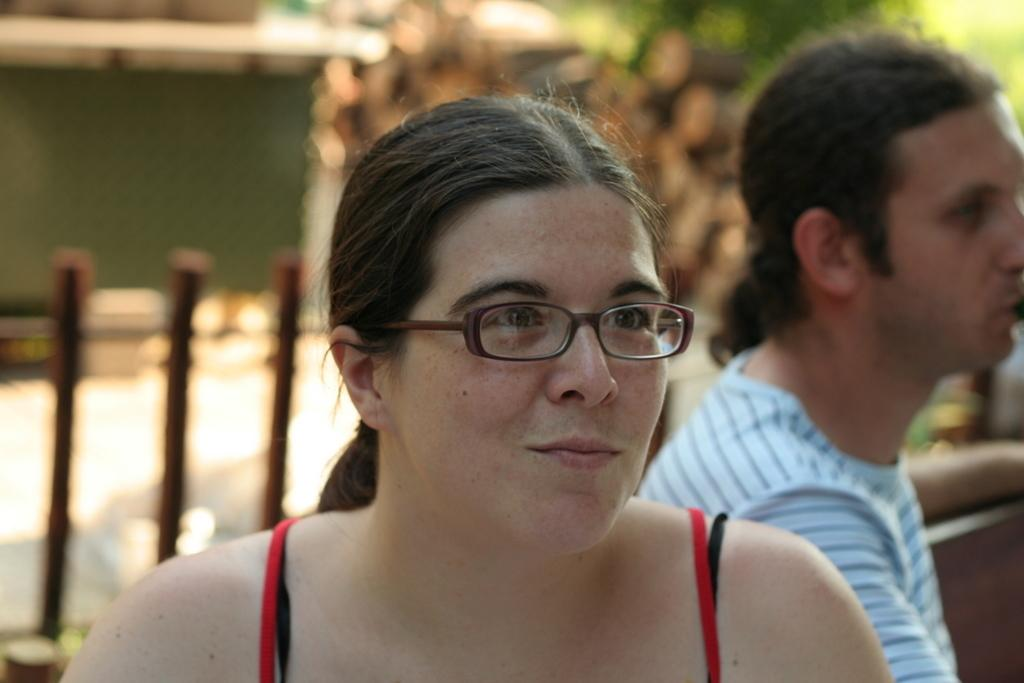How many people are in the image? There are two people in the image. What can be seen in the background of the image? Trees are visible in the image. What type of establishment is present in the image? There is a shop in the image. What is the primary mode of transportation visible in the image? There is a road in the image. What type of furniture is present in the image? There is a chair in the image. Who is the manager of the shop in the image? The image does not provide information about the management of the shop, so it cannot be determined from the image. 